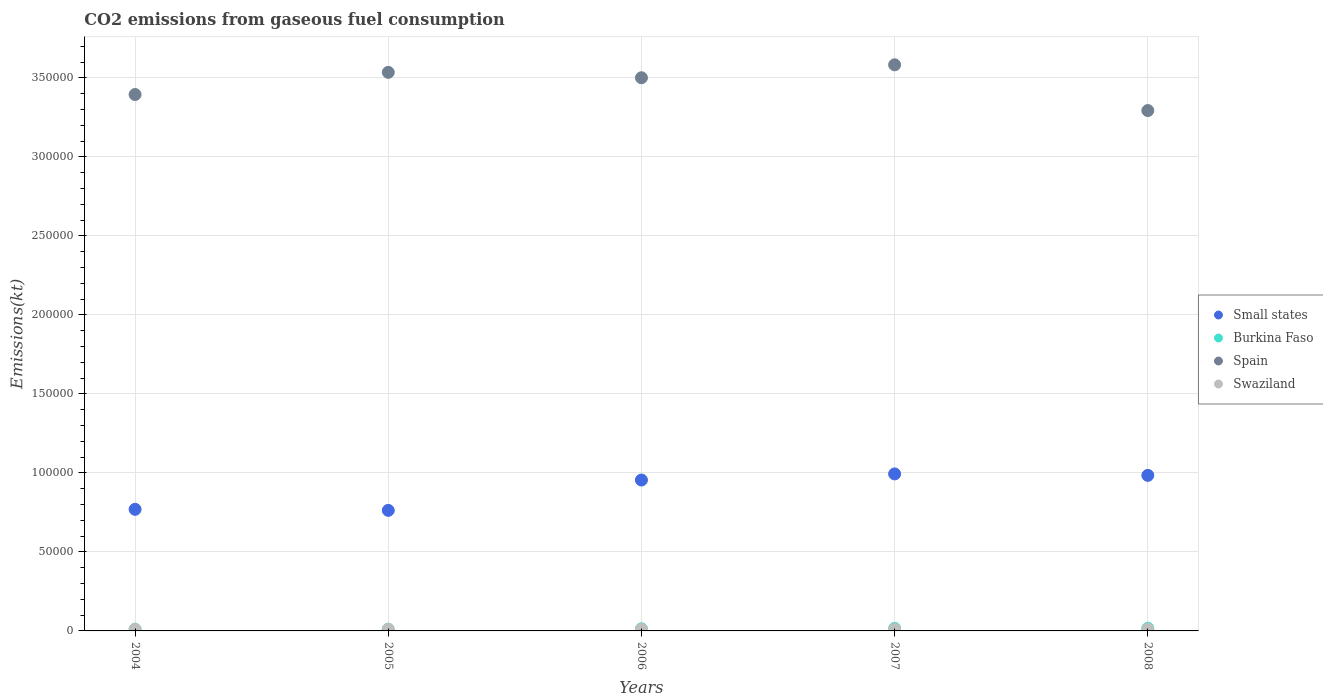Is the number of dotlines equal to the number of legend labels?
Keep it short and to the point. Yes. What is the amount of CO2 emitted in Spain in 2008?
Give a very brief answer. 3.29e+05. Across all years, what is the maximum amount of CO2 emitted in Spain?
Keep it short and to the point. 3.58e+05. Across all years, what is the minimum amount of CO2 emitted in Spain?
Offer a very short reply. 3.29e+05. In which year was the amount of CO2 emitted in Swaziland maximum?
Ensure brevity in your answer.  2008. In which year was the amount of CO2 emitted in Burkina Faso minimum?
Keep it short and to the point. 2004. What is the total amount of CO2 emitted in Small states in the graph?
Your response must be concise. 4.47e+05. What is the difference between the amount of CO2 emitted in Spain in 2007 and that in 2008?
Make the answer very short. 2.90e+04. What is the difference between the amount of CO2 emitted in Swaziland in 2005 and the amount of CO2 emitted in Burkina Faso in 2007?
Your answer should be compact. -627.06. What is the average amount of CO2 emitted in Spain per year?
Offer a terse response. 3.46e+05. In the year 2006, what is the difference between the amount of CO2 emitted in Burkina Faso and amount of CO2 emitted in Spain?
Your answer should be very brief. -3.49e+05. In how many years, is the amount of CO2 emitted in Swaziland greater than 190000 kt?
Offer a terse response. 0. What is the ratio of the amount of CO2 emitted in Swaziland in 2006 to that in 2008?
Ensure brevity in your answer.  0.93. Is the amount of CO2 emitted in Spain in 2005 less than that in 2007?
Offer a very short reply. Yes. What is the difference between the highest and the second highest amount of CO2 emitted in Spain?
Your answer should be compact. 4774.43. What is the difference between the highest and the lowest amount of CO2 emitted in Small states?
Ensure brevity in your answer.  2.31e+04. In how many years, is the amount of CO2 emitted in Burkina Faso greater than the average amount of CO2 emitted in Burkina Faso taken over all years?
Offer a terse response. 2. Is the sum of the amount of CO2 emitted in Burkina Faso in 2006 and 2008 greater than the maximum amount of CO2 emitted in Swaziland across all years?
Offer a very short reply. Yes. Is it the case that in every year, the sum of the amount of CO2 emitted in Small states and amount of CO2 emitted in Swaziland  is greater than the sum of amount of CO2 emitted in Burkina Faso and amount of CO2 emitted in Spain?
Make the answer very short. No. Is it the case that in every year, the sum of the amount of CO2 emitted in Swaziland and amount of CO2 emitted in Spain  is greater than the amount of CO2 emitted in Small states?
Offer a terse response. Yes. Is the amount of CO2 emitted in Burkina Faso strictly greater than the amount of CO2 emitted in Small states over the years?
Your answer should be very brief. No. How many years are there in the graph?
Your answer should be compact. 5. What is the difference between two consecutive major ticks on the Y-axis?
Make the answer very short. 5.00e+04. Does the graph contain any zero values?
Provide a succinct answer. No. How many legend labels are there?
Offer a very short reply. 4. What is the title of the graph?
Give a very brief answer. CO2 emissions from gaseous fuel consumption. Does "Slovenia" appear as one of the legend labels in the graph?
Provide a succinct answer. No. What is the label or title of the X-axis?
Provide a succinct answer. Years. What is the label or title of the Y-axis?
Offer a terse response. Emissions(kt). What is the Emissions(kt) in Small states in 2004?
Keep it short and to the point. 7.69e+04. What is the Emissions(kt) of Burkina Faso in 2004?
Keep it short and to the point. 1103.77. What is the Emissions(kt) in Spain in 2004?
Offer a terse response. 3.39e+05. What is the Emissions(kt) in Swaziland in 2004?
Keep it short and to the point. 1030.43. What is the Emissions(kt) of Small states in 2005?
Offer a terse response. 7.63e+04. What is the Emissions(kt) in Burkina Faso in 2005?
Provide a succinct answer. 1125.77. What is the Emissions(kt) of Spain in 2005?
Your response must be concise. 3.53e+05. What is the Emissions(kt) of Swaziland in 2005?
Your answer should be very brief. 1019.43. What is the Emissions(kt) in Small states in 2006?
Offer a terse response. 9.55e+04. What is the Emissions(kt) of Burkina Faso in 2006?
Your response must be concise. 1360.46. What is the Emissions(kt) in Spain in 2006?
Ensure brevity in your answer.  3.50e+05. What is the Emissions(kt) of Swaziland in 2006?
Give a very brief answer. 1015.76. What is the Emissions(kt) in Small states in 2007?
Make the answer very short. 9.94e+04. What is the Emissions(kt) of Burkina Faso in 2007?
Ensure brevity in your answer.  1646.48. What is the Emissions(kt) of Spain in 2007?
Provide a short and direct response. 3.58e+05. What is the Emissions(kt) in Swaziland in 2007?
Offer a very short reply. 1063.43. What is the Emissions(kt) in Small states in 2008?
Give a very brief answer. 9.84e+04. What is the Emissions(kt) of Burkina Faso in 2008?
Give a very brief answer. 1697.82. What is the Emissions(kt) of Spain in 2008?
Your response must be concise. 3.29e+05. What is the Emissions(kt) in Swaziland in 2008?
Offer a terse response. 1096.43. Across all years, what is the maximum Emissions(kt) of Small states?
Provide a succinct answer. 9.94e+04. Across all years, what is the maximum Emissions(kt) in Burkina Faso?
Your answer should be very brief. 1697.82. Across all years, what is the maximum Emissions(kt) of Spain?
Make the answer very short. 3.58e+05. Across all years, what is the maximum Emissions(kt) in Swaziland?
Your answer should be very brief. 1096.43. Across all years, what is the minimum Emissions(kt) in Small states?
Offer a very short reply. 7.63e+04. Across all years, what is the minimum Emissions(kt) of Burkina Faso?
Provide a short and direct response. 1103.77. Across all years, what is the minimum Emissions(kt) in Spain?
Ensure brevity in your answer.  3.29e+05. Across all years, what is the minimum Emissions(kt) of Swaziland?
Provide a short and direct response. 1015.76. What is the total Emissions(kt) in Small states in the graph?
Ensure brevity in your answer.  4.47e+05. What is the total Emissions(kt) of Burkina Faso in the graph?
Offer a terse response. 6934.3. What is the total Emissions(kt) in Spain in the graph?
Offer a terse response. 1.73e+06. What is the total Emissions(kt) of Swaziland in the graph?
Provide a succinct answer. 5225.48. What is the difference between the Emissions(kt) in Small states in 2004 and that in 2005?
Give a very brief answer. 657.26. What is the difference between the Emissions(kt) of Burkina Faso in 2004 and that in 2005?
Ensure brevity in your answer.  -22. What is the difference between the Emissions(kt) in Spain in 2004 and that in 2005?
Your answer should be compact. -1.40e+04. What is the difference between the Emissions(kt) of Swaziland in 2004 and that in 2005?
Keep it short and to the point. 11. What is the difference between the Emissions(kt) of Small states in 2004 and that in 2006?
Provide a short and direct response. -1.85e+04. What is the difference between the Emissions(kt) in Burkina Faso in 2004 and that in 2006?
Make the answer very short. -256.69. What is the difference between the Emissions(kt) of Spain in 2004 and that in 2006?
Ensure brevity in your answer.  -1.06e+04. What is the difference between the Emissions(kt) of Swaziland in 2004 and that in 2006?
Provide a short and direct response. 14.67. What is the difference between the Emissions(kt) of Small states in 2004 and that in 2007?
Give a very brief answer. -2.24e+04. What is the difference between the Emissions(kt) in Burkina Faso in 2004 and that in 2007?
Make the answer very short. -542.72. What is the difference between the Emissions(kt) of Spain in 2004 and that in 2007?
Your answer should be compact. -1.88e+04. What is the difference between the Emissions(kt) of Swaziland in 2004 and that in 2007?
Ensure brevity in your answer.  -33. What is the difference between the Emissions(kt) of Small states in 2004 and that in 2008?
Provide a short and direct response. -2.15e+04. What is the difference between the Emissions(kt) in Burkina Faso in 2004 and that in 2008?
Your answer should be compact. -594.05. What is the difference between the Emissions(kt) of Spain in 2004 and that in 2008?
Your answer should be compact. 1.01e+04. What is the difference between the Emissions(kt) in Swaziland in 2004 and that in 2008?
Your answer should be compact. -66.01. What is the difference between the Emissions(kt) of Small states in 2005 and that in 2006?
Keep it short and to the point. -1.92e+04. What is the difference between the Emissions(kt) of Burkina Faso in 2005 and that in 2006?
Provide a succinct answer. -234.69. What is the difference between the Emissions(kt) in Spain in 2005 and that in 2006?
Give a very brief answer. 3424.98. What is the difference between the Emissions(kt) in Swaziland in 2005 and that in 2006?
Offer a terse response. 3.67. What is the difference between the Emissions(kt) in Small states in 2005 and that in 2007?
Ensure brevity in your answer.  -2.31e+04. What is the difference between the Emissions(kt) of Burkina Faso in 2005 and that in 2007?
Make the answer very short. -520.71. What is the difference between the Emissions(kt) in Spain in 2005 and that in 2007?
Keep it short and to the point. -4774.43. What is the difference between the Emissions(kt) of Swaziland in 2005 and that in 2007?
Provide a short and direct response. -44. What is the difference between the Emissions(kt) in Small states in 2005 and that in 2008?
Give a very brief answer. -2.21e+04. What is the difference between the Emissions(kt) of Burkina Faso in 2005 and that in 2008?
Provide a short and direct response. -572.05. What is the difference between the Emissions(kt) in Spain in 2005 and that in 2008?
Your answer should be very brief. 2.42e+04. What is the difference between the Emissions(kt) in Swaziland in 2005 and that in 2008?
Keep it short and to the point. -77.01. What is the difference between the Emissions(kt) of Small states in 2006 and that in 2007?
Offer a very short reply. -3870.17. What is the difference between the Emissions(kt) of Burkina Faso in 2006 and that in 2007?
Your response must be concise. -286.03. What is the difference between the Emissions(kt) in Spain in 2006 and that in 2007?
Your response must be concise. -8199.41. What is the difference between the Emissions(kt) of Swaziland in 2006 and that in 2007?
Offer a terse response. -47.67. What is the difference between the Emissions(kt) in Small states in 2006 and that in 2008?
Your response must be concise. -2949.4. What is the difference between the Emissions(kt) of Burkina Faso in 2006 and that in 2008?
Provide a succinct answer. -337.36. What is the difference between the Emissions(kt) in Spain in 2006 and that in 2008?
Offer a very short reply. 2.08e+04. What is the difference between the Emissions(kt) of Swaziland in 2006 and that in 2008?
Offer a terse response. -80.67. What is the difference between the Emissions(kt) in Small states in 2007 and that in 2008?
Keep it short and to the point. 920.77. What is the difference between the Emissions(kt) in Burkina Faso in 2007 and that in 2008?
Your answer should be compact. -51.34. What is the difference between the Emissions(kt) in Spain in 2007 and that in 2008?
Make the answer very short. 2.90e+04. What is the difference between the Emissions(kt) in Swaziland in 2007 and that in 2008?
Keep it short and to the point. -33. What is the difference between the Emissions(kt) in Small states in 2004 and the Emissions(kt) in Burkina Faso in 2005?
Your answer should be very brief. 7.58e+04. What is the difference between the Emissions(kt) of Small states in 2004 and the Emissions(kt) of Spain in 2005?
Your response must be concise. -2.77e+05. What is the difference between the Emissions(kt) in Small states in 2004 and the Emissions(kt) in Swaziland in 2005?
Keep it short and to the point. 7.59e+04. What is the difference between the Emissions(kt) in Burkina Faso in 2004 and the Emissions(kt) in Spain in 2005?
Keep it short and to the point. -3.52e+05. What is the difference between the Emissions(kt) in Burkina Faso in 2004 and the Emissions(kt) in Swaziland in 2005?
Keep it short and to the point. 84.34. What is the difference between the Emissions(kt) in Spain in 2004 and the Emissions(kt) in Swaziland in 2005?
Your response must be concise. 3.38e+05. What is the difference between the Emissions(kt) of Small states in 2004 and the Emissions(kt) of Burkina Faso in 2006?
Make the answer very short. 7.56e+04. What is the difference between the Emissions(kt) in Small states in 2004 and the Emissions(kt) in Spain in 2006?
Offer a very short reply. -2.73e+05. What is the difference between the Emissions(kt) of Small states in 2004 and the Emissions(kt) of Swaziland in 2006?
Your answer should be compact. 7.59e+04. What is the difference between the Emissions(kt) in Burkina Faso in 2004 and the Emissions(kt) in Spain in 2006?
Offer a very short reply. -3.49e+05. What is the difference between the Emissions(kt) of Burkina Faso in 2004 and the Emissions(kt) of Swaziland in 2006?
Keep it short and to the point. 88.01. What is the difference between the Emissions(kt) of Spain in 2004 and the Emissions(kt) of Swaziland in 2006?
Provide a succinct answer. 3.38e+05. What is the difference between the Emissions(kt) of Small states in 2004 and the Emissions(kt) of Burkina Faso in 2007?
Offer a terse response. 7.53e+04. What is the difference between the Emissions(kt) in Small states in 2004 and the Emissions(kt) in Spain in 2007?
Provide a succinct answer. -2.81e+05. What is the difference between the Emissions(kt) of Small states in 2004 and the Emissions(kt) of Swaziland in 2007?
Provide a short and direct response. 7.59e+04. What is the difference between the Emissions(kt) of Burkina Faso in 2004 and the Emissions(kt) of Spain in 2007?
Your answer should be compact. -3.57e+05. What is the difference between the Emissions(kt) in Burkina Faso in 2004 and the Emissions(kt) in Swaziland in 2007?
Your answer should be compact. 40.34. What is the difference between the Emissions(kt) of Spain in 2004 and the Emissions(kt) of Swaziland in 2007?
Give a very brief answer. 3.38e+05. What is the difference between the Emissions(kt) in Small states in 2004 and the Emissions(kt) in Burkina Faso in 2008?
Provide a short and direct response. 7.52e+04. What is the difference between the Emissions(kt) of Small states in 2004 and the Emissions(kt) of Spain in 2008?
Offer a terse response. -2.52e+05. What is the difference between the Emissions(kt) in Small states in 2004 and the Emissions(kt) in Swaziland in 2008?
Provide a short and direct response. 7.58e+04. What is the difference between the Emissions(kt) in Burkina Faso in 2004 and the Emissions(kt) in Spain in 2008?
Keep it short and to the point. -3.28e+05. What is the difference between the Emissions(kt) of Burkina Faso in 2004 and the Emissions(kt) of Swaziland in 2008?
Offer a terse response. 7.33. What is the difference between the Emissions(kt) in Spain in 2004 and the Emissions(kt) in Swaziland in 2008?
Your answer should be very brief. 3.38e+05. What is the difference between the Emissions(kt) in Small states in 2005 and the Emissions(kt) in Burkina Faso in 2006?
Your response must be concise. 7.49e+04. What is the difference between the Emissions(kt) of Small states in 2005 and the Emissions(kt) of Spain in 2006?
Your answer should be compact. -2.74e+05. What is the difference between the Emissions(kt) of Small states in 2005 and the Emissions(kt) of Swaziland in 2006?
Keep it short and to the point. 7.53e+04. What is the difference between the Emissions(kt) in Burkina Faso in 2005 and the Emissions(kt) in Spain in 2006?
Offer a very short reply. -3.49e+05. What is the difference between the Emissions(kt) in Burkina Faso in 2005 and the Emissions(kt) in Swaziland in 2006?
Give a very brief answer. 110.01. What is the difference between the Emissions(kt) in Spain in 2005 and the Emissions(kt) in Swaziland in 2006?
Ensure brevity in your answer.  3.52e+05. What is the difference between the Emissions(kt) in Small states in 2005 and the Emissions(kt) in Burkina Faso in 2007?
Provide a short and direct response. 7.46e+04. What is the difference between the Emissions(kt) of Small states in 2005 and the Emissions(kt) of Spain in 2007?
Provide a succinct answer. -2.82e+05. What is the difference between the Emissions(kt) in Small states in 2005 and the Emissions(kt) in Swaziland in 2007?
Provide a short and direct response. 7.52e+04. What is the difference between the Emissions(kt) of Burkina Faso in 2005 and the Emissions(kt) of Spain in 2007?
Give a very brief answer. -3.57e+05. What is the difference between the Emissions(kt) of Burkina Faso in 2005 and the Emissions(kt) of Swaziland in 2007?
Provide a short and direct response. 62.34. What is the difference between the Emissions(kt) in Spain in 2005 and the Emissions(kt) in Swaziland in 2007?
Provide a short and direct response. 3.52e+05. What is the difference between the Emissions(kt) of Small states in 2005 and the Emissions(kt) of Burkina Faso in 2008?
Give a very brief answer. 7.46e+04. What is the difference between the Emissions(kt) of Small states in 2005 and the Emissions(kt) of Spain in 2008?
Your answer should be very brief. -2.53e+05. What is the difference between the Emissions(kt) in Small states in 2005 and the Emissions(kt) in Swaziland in 2008?
Your answer should be very brief. 7.52e+04. What is the difference between the Emissions(kt) of Burkina Faso in 2005 and the Emissions(kt) of Spain in 2008?
Your answer should be compact. -3.28e+05. What is the difference between the Emissions(kt) in Burkina Faso in 2005 and the Emissions(kt) in Swaziland in 2008?
Provide a short and direct response. 29.34. What is the difference between the Emissions(kt) in Spain in 2005 and the Emissions(kt) in Swaziland in 2008?
Make the answer very short. 3.52e+05. What is the difference between the Emissions(kt) of Small states in 2006 and the Emissions(kt) of Burkina Faso in 2007?
Your answer should be compact. 9.38e+04. What is the difference between the Emissions(kt) in Small states in 2006 and the Emissions(kt) in Spain in 2007?
Provide a succinct answer. -2.63e+05. What is the difference between the Emissions(kt) of Small states in 2006 and the Emissions(kt) of Swaziland in 2007?
Your response must be concise. 9.44e+04. What is the difference between the Emissions(kt) in Burkina Faso in 2006 and the Emissions(kt) in Spain in 2007?
Keep it short and to the point. -3.57e+05. What is the difference between the Emissions(kt) of Burkina Faso in 2006 and the Emissions(kt) of Swaziland in 2007?
Your answer should be compact. 297.03. What is the difference between the Emissions(kt) in Spain in 2006 and the Emissions(kt) in Swaziland in 2007?
Ensure brevity in your answer.  3.49e+05. What is the difference between the Emissions(kt) of Small states in 2006 and the Emissions(kt) of Burkina Faso in 2008?
Provide a succinct answer. 9.38e+04. What is the difference between the Emissions(kt) of Small states in 2006 and the Emissions(kt) of Spain in 2008?
Your answer should be compact. -2.34e+05. What is the difference between the Emissions(kt) in Small states in 2006 and the Emissions(kt) in Swaziland in 2008?
Give a very brief answer. 9.44e+04. What is the difference between the Emissions(kt) in Burkina Faso in 2006 and the Emissions(kt) in Spain in 2008?
Provide a short and direct response. -3.28e+05. What is the difference between the Emissions(kt) of Burkina Faso in 2006 and the Emissions(kt) of Swaziland in 2008?
Offer a terse response. 264.02. What is the difference between the Emissions(kt) of Spain in 2006 and the Emissions(kt) of Swaziland in 2008?
Your answer should be very brief. 3.49e+05. What is the difference between the Emissions(kt) in Small states in 2007 and the Emissions(kt) in Burkina Faso in 2008?
Give a very brief answer. 9.77e+04. What is the difference between the Emissions(kt) in Small states in 2007 and the Emissions(kt) in Spain in 2008?
Your answer should be very brief. -2.30e+05. What is the difference between the Emissions(kt) of Small states in 2007 and the Emissions(kt) of Swaziland in 2008?
Provide a short and direct response. 9.83e+04. What is the difference between the Emissions(kt) of Burkina Faso in 2007 and the Emissions(kt) of Spain in 2008?
Make the answer very short. -3.28e+05. What is the difference between the Emissions(kt) in Burkina Faso in 2007 and the Emissions(kt) in Swaziland in 2008?
Your response must be concise. 550.05. What is the difference between the Emissions(kt) in Spain in 2007 and the Emissions(kt) in Swaziland in 2008?
Offer a terse response. 3.57e+05. What is the average Emissions(kt) of Small states per year?
Your response must be concise. 8.93e+04. What is the average Emissions(kt) of Burkina Faso per year?
Provide a succinct answer. 1386.86. What is the average Emissions(kt) in Spain per year?
Make the answer very short. 3.46e+05. What is the average Emissions(kt) of Swaziland per year?
Give a very brief answer. 1045.1. In the year 2004, what is the difference between the Emissions(kt) in Small states and Emissions(kt) in Burkina Faso?
Make the answer very short. 7.58e+04. In the year 2004, what is the difference between the Emissions(kt) in Small states and Emissions(kt) in Spain?
Offer a very short reply. -2.62e+05. In the year 2004, what is the difference between the Emissions(kt) in Small states and Emissions(kt) in Swaziland?
Your response must be concise. 7.59e+04. In the year 2004, what is the difference between the Emissions(kt) in Burkina Faso and Emissions(kt) in Spain?
Your response must be concise. -3.38e+05. In the year 2004, what is the difference between the Emissions(kt) in Burkina Faso and Emissions(kt) in Swaziland?
Your answer should be compact. 73.34. In the year 2004, what is the difference between the Emissions(kt) of Spain and Emissions(kt) of Swaziland?
Keep it short and to the point. 3.38e+05. In the year 2005, what is the difference between the Emissions(kt) in Small states and Emissions(kt) in Burkina Faso?
Keep it short and to the point. 7.52e+04. In the year 2005, what is the difference between the Emissions(kt) of Small states and Emissions(kt) of Spain?
Keep it short and to the point. -2.77e+05. In the year 2005, what is the difference between the Emissions(kt) of Small states and Emissions(kt) of Swaziland?
Keep it short and to the point. 7.53e+04. In the year 2005, what is the difference between the Emissions(kt) in Burkina Faso and Emissions(kt) in Spain?
Provide a short and direct response. -3.52e+05. In the year 2005, what is the difference between the Emissions(kt) of Burkina Faso and Emissions(kt) of Swaziland?
Make the answer very short. 106.34. In the year 2005, what is the difference between the Emissions(kt) of Spain and Emissions(kt) of Swaziland?
Give a very brief answer. 3.52e+05. In the year 2006, what is the difference between the Emissions(kt) of Small states and Emissions(kt) of Burkina Faso?
Provide a succinct answer. 9.41e+04. In the year 2006, what is the difference between the Emissions(kt) in Small states and Emissions(kt) in Spain?
Your answer should be compact. -2.55e+05. In the year 2006, what is the difference between the Emissions(kt) of Small states and Emissions(kt) of Swaziland?
Your answer should be very brief. 9.45e+04. In the year 2006, what is the difference between the Emissions(kt) of Burkina Faso and Emissions(kt) of Spain?
Provide a short and direct response. -3.49e+05. In the year 2006, what is the difference between the Emissions(kt) in Burkina Faso and Emissions(kt) in Swaziland?
Offer a terse response. 344.7. In the year 2006, what is the difference between the Emissions(kt) in Spain and Emissions(kt) in Swaziland?
Ensure brevity in your answer.  3.49e+05. In the year 2007, what is the difference between the Emissions(kt) in Small states and Emissions(kt) in Burkina Faso?
Provide a succinct answer. 9.77e+04. In the year 2007, what is the difference between the Emissions(kt) of Small states and Emissions(kt) of Spain?
Offer a terse response. -2.59e+05. In the year 2007, what is the difference between the Emissions(kt) in Small states and Emissions(kt) in Swaziland?
Your answer should be compact. 9.83e+04. In the year 2007, what is the difference between the Emissions(kt) of Burkina Faso and Emissions(kt) of Spain?
Provide a succinct answer. -3.57e+05. In the year 2007, what is the difference between the Emissions(kt) in Burkina Faso and Emissions(kt) in Swaziland?
Your answer should be very brief. 583.05. In the year 2007, what is the difference between the Emissions(kt) in Spain and Emissions(kt) in Swaziland?
Your answer should be very brief. 3.57e+05. In the year 2008, what is the difference between the Emissions(kt) of Small states and Emissions(kt) of Burkina Faso?
Ensure brevity in your answer.  9.67e+04. In the year 2008, what is the difference between the Emissions(kt) in Small states and Emissions(kt) in Spain?
Your answer should be very brief. -2.31e+05. In the year 2008, what is the difference between the Emissions(kt) of Small states and Emissions(kt) of Swaziland?
Offer a very short reply. 9.73e+04. In the year 2008, what is the difference between the Emissions(kt) in Burkina Faso and Emissions(kt) in Spain?
Your response must be concise. -3.28e+05. In the year 2008, what is the difference between the Emissions(kt) in Burkina Faso and Emissions(kt) in Swaziland?
Give a very brief answer. 601.39. In the year 2008, what is the difference between the Emissions(kt) of Spain and Emissions(kt) of Swaziland?
Give a very brief answer. 3.28e+05. What is the ratio of the Emissions(kt) of Small states in 2004 to that in 2005?
Ensure brevity in your answer.  1.01. What is the ratio of the Emissions(kt) in Burkina Faso in 2004 to that in 2005?
Keep it short and to the point. 0.98. What is the ratio of the Emissions(kt) of Spain in 2004 to that in 2005?
Offer a very short reply. 0.96. What is the ratio of the Emissions(kt) of Swaziland in 2004 to that in 2005?
Offer a terse response. 1.01. What is the ratio of the Emissions(kt) in Small states in 2004 to that in 2006?
Give a very brief answer. 0.81. What is the ratio of the Emissions(kt) of Burkina Faso in 2004 to that in 2006?
Make the answer very short. 0.81. What is the ratio of the Emissions(kt) of Spain in 2004 to that in 2006?
Keep it short and to the point. 0.97. What is the ratio of the Emissions(kt) of Swaziland in 2004 to that in 2006?
Offer a very short reply. 1.01. What is the ratio of the Emissions(kt) in Small states in 2004 to that in 2007?
Offer a very short reply. 0.77. What is the ratio of the Emissions(kt) of Burkina Faso in 2004 to that in 2007?
Give a very brief answer. 0.67. What is the ratio of the Emissions(kt) of Spain in 2004 to that in 2007?
Provide a succinct answer. 0.95. What is the ratio of the Emissions(kt) of Small states in 2004 to that in 2008?
Make the answer very short. 0.78. What is the ratio of the Emissions(kt) in Burkina Faso in 2004 to that in 2008?
Provide a succinct answer. 0.65. What is the ratio of the Emissions(kt) of Spain in 2004 to that in 2008?
Your answer should be very brief. 1.03. What is the ratio of the Emissions(kt) of Swaziland in 2004 to that in 2008?
Ensure brevity in your answer.  0.94. What is the ratio of the Emissions(kt) of Small states in 2005 to that in 2006?
Provide a short and direct response. 0.8. What is the ratio of the Emissions(kt) of Burkina Faso in 2005 to that in 2006?
Your answer should be compact. 0.83. What is the ratio of the Emissions(kt) of Spain in 2005 to that in 2006?
Provide a short and direct response. 1.01. What is the ratio of the Emissions(kt) in Swaziland in 2005 to that in 2006?
Provide a short and direct response. 1. What is the ratio of the Emissions(kt) of Small states in 2005 to that in 2007?
Make the answer very short. 0.77. What is the ratio of the Emissions(kt) of Burkina Faso in 2005 to that in 2007?
Make the answer very short. 0.68. What is the ratio of the Emissions(kt) in Spain in 2005 to that in 2007?
Offer a very short reply. 0.99. What is the ratio of the Emissions(kt) in Swaziland in 2005 to that in 2007?
Ensure brevity in your answer.  0.96. What is the ratio of the Emissions(kt) of Small states in 2005 to that in 2008?
Provide a succinct answer. 0.78. What is the ratio of the Emissions(kt) of Burkina Faso in 2005 to that in 2008?
Provide a succinct answer. 0.66. What is the ratio of the Emissions(kt) of Spain in 2005 to that in 2008?
Offer a very short reply. 1.07. What is the ratio of the Emissions(kt) of Swaziland in 2005 to that in 2008?
Offer a terse response. 0.93. What is the ratio of the Emissions(kt) in Burkina Faso in 2006 to that in 2007?
Provide a short and direct response. 0.83. What is the ratio of the Emissions(kt) of Spain in 2006 to that in 2007?
Provide a short and direct response. 0.98. What is the ratio of the Emissions(kt) in Swaziland in 2006 to that in 2007?
Your response must be concise. 0.96. What is the ratio of the Emissions(kt) of Small states in 2006 to that in 2008?
Offer a terse response. 0.97. What is the ratio of the Emissions(kt) in Burkina Faso in 2006 to that in 2008?
Offer a terse response. 0.8. What is the ratio of the Emissions(kt) of Spain in 2006 to that in 2008?
Your answer should be compact. 1.06. What is the ratio of the Emissions(kt) of Swaziland in 2006 to that in 2008?
Keep it short and to the point. 0.93. What is the ratio of the Emissions(kt) of Small states in 2007 to that in 2008?
Offer a terse response. 1.01. What is the ratio of the Emissions(kt) in Burkina Faso in 2007 to that in 2008?
Ensure brevity in your answer.  0.97. What is the ratio of the Emissions(kt) in Spain in 2007 to that in 2008?
Offer a very short reply. 1.09. What is the ratio of the Emissions(kt) in Swaziland in 2007 to that in 2008?
Ensure brevity in your answer.  0.97. What is the difference between the highest and the second highest Emissions(kt) of Small states?
Provide a short and direct response. 920.77. What is the difference between the highest and the second highest Emissions(kt) in Burkina Faso?
Ensure brevity in your answer.  51.34. What is the difference between the highest and the second highest Emissions(kt) in Spain?
Give a very brief answer. 4774.43. What is the difference between the highest and the second highest Emissions(kt) of Swaziland?
Your answer should be very brief. 33. What is the difference between the highest and the lowest Emissions(kt) in Small states?
Offer a very short reply. 2.31e+04. What is the difference between the highest and the lowest Emissions(kt) in Burkina Faso?
Give a very brief answer. 594.05. What is the difference between the highest and the lowest Emissions(kt) of Spain?
Offer a terse response. 2.90e+04. What is the difference between the highest and the lowest Emissions(kt) of Swaziland?
Your answer should be compact. 80.67. 